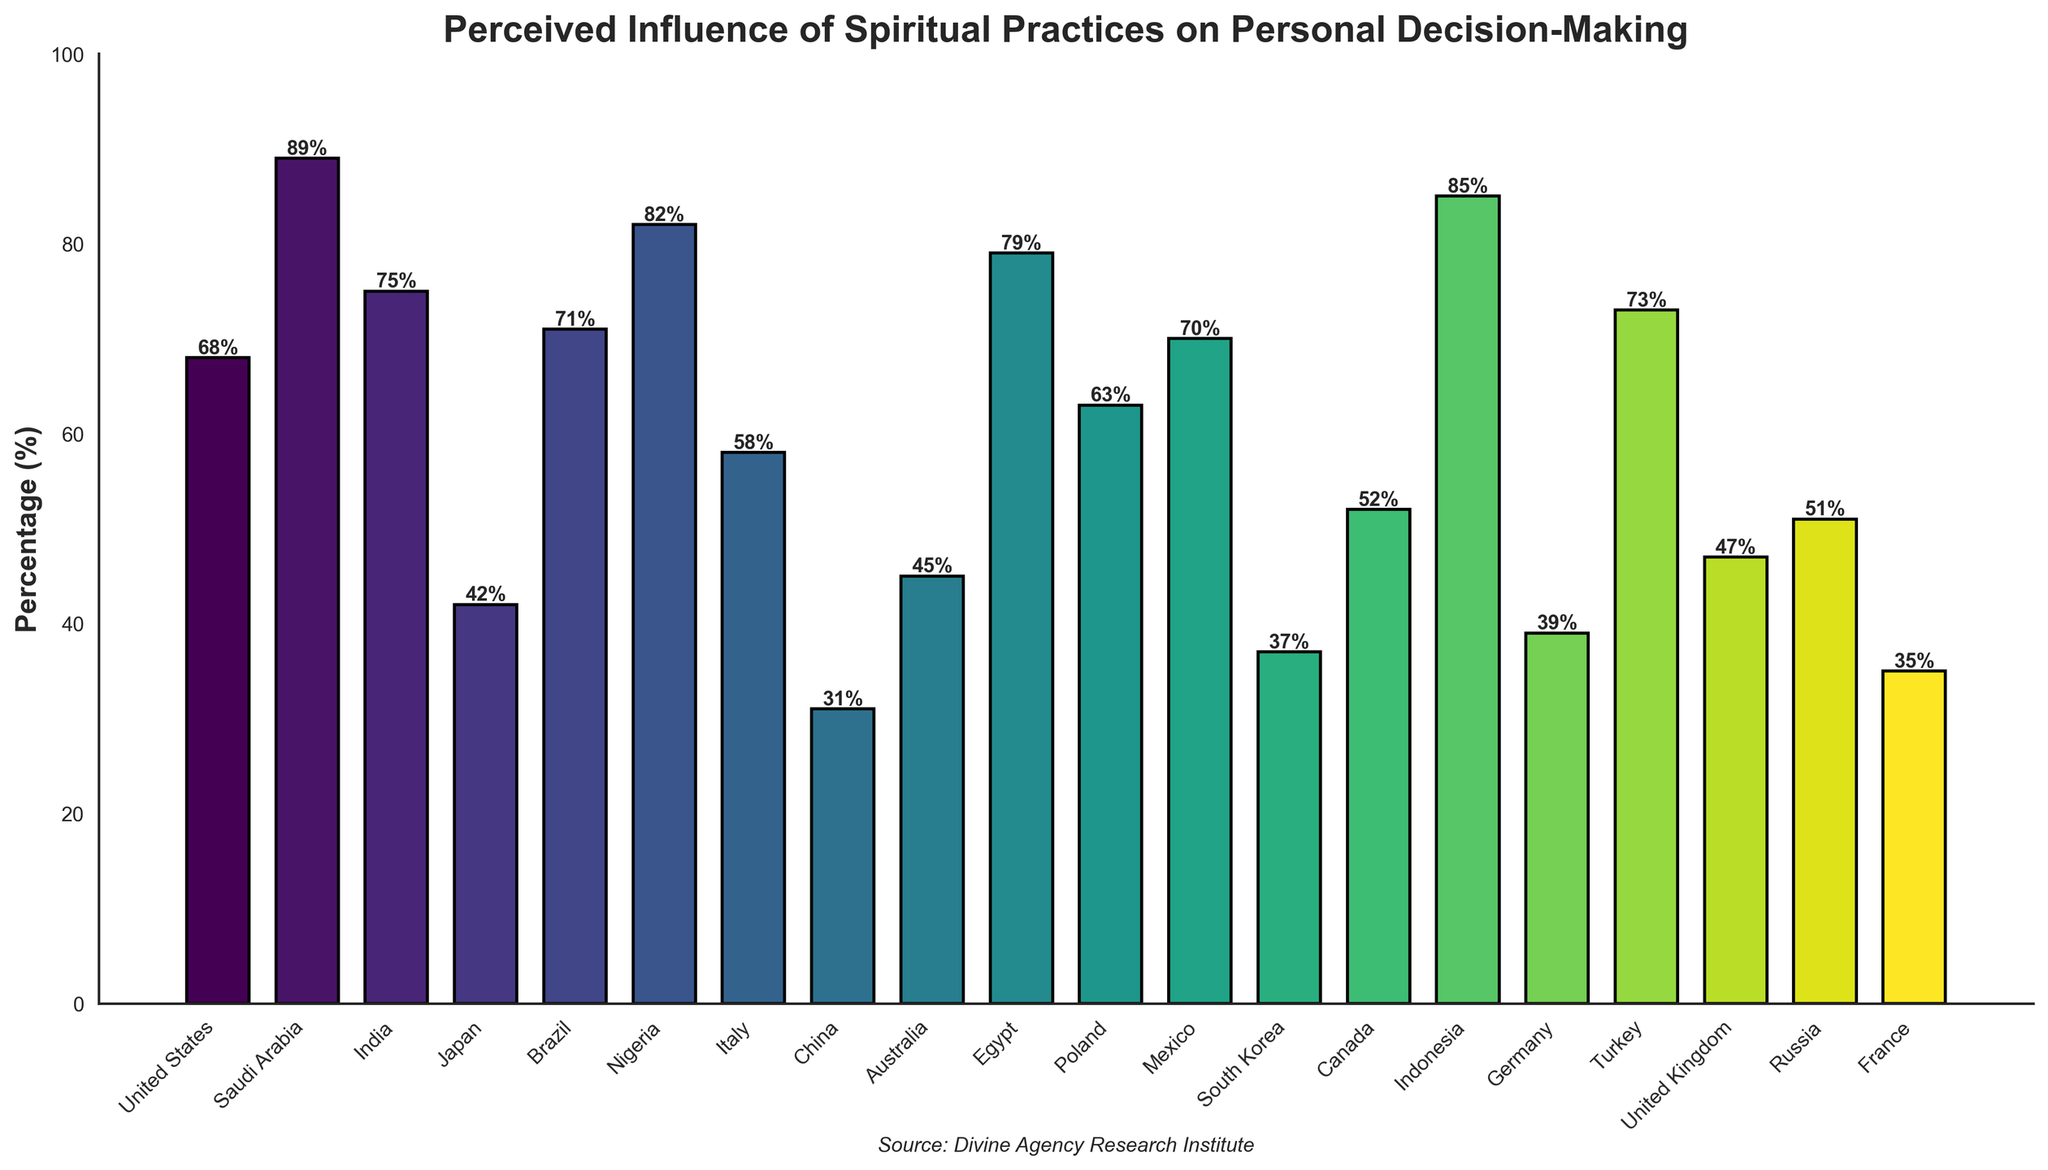Which culture reported the highest percentage of significant spiritual influence? To determine the highest percentage, compare the height of the bars for each culture. The tallest bar represents the highest percentage.
Answer: Saudi Arabia Which culture reported the lowest percentage of significant spiritual influence? Look for the shortest bar in the figure, it represents the lowest percentage of significant spiritual influence.
Answer: China What's the difference in the reported percentage of significant spiritual influence between the United States and Japan? Find the heights of the bars for the United States (68%) and Japan (42%), then subtract the smaller percentage from the larger one. 68% - 42% = 26%.
Answer: 26% Which has a higher percentage of reported significant spiritual influence: Brazil or France? Compare the heights of the bars for Brazil (71%) and France (35%). Since Brazil's bar is higher, Brazil has a higher percentage.
Answer: Brazil What's the combined percentage of reported significant spiritual influence for Nigeria and Mexico? Add the percentages for Nigeria (82%) and Mexico (70%). 82% + 70% = 152%.
Answer: 152% How does the percentage of reported significant spiritual influence in the United Kingdom compare to Canada? Compare the heights of the bars for the United Kingdom (47%) and Canada (52%). The bar for Canada is slightly higher.
Answer: Canada Is the percentage of reported significant spiritual influence higher in Turkey or Germany, and by how much? Find the heights of the bars for Turkey (73%) and Germany (39%). Subtract the smaller percentage from the larger one. 73% - 39% = 34%.
Answer: Turkey, by 34% What is the average percentage of reported significant spiritual influence across all listed cultures? Add all the reported percentages: (68 + 89 + 75 + 42 + 71 + 82 + 58 + 31 + 45 + 79 + 63 + 70 + 37 + 52 + 85 + 39 + 73 + 47 + 51 + 35) = 1211. Divide by the number of cultures (20). 1211 / 20 = 60.55%.
Answer: 60.55% Which three cultures are closest in their reported percentage of significant spiritual influence? Look for groups of three bars that have similar heights. The closest percentages are from Russia (51%), Canada (52%), and the United Kingdom (47%).
Answer: Russia, Canada, United Kingdom How many cultures reported a percentage of significant spiritual influence higher than the global average of 60.55%? Identify and count the bars with a height greater than 60.55%. The cultures are United States, Saudi Arabia, India, Brazil, Nigeria, Egypt, Mexico, and Indonesia, making a total of 8 cultures.
Answer: 8 